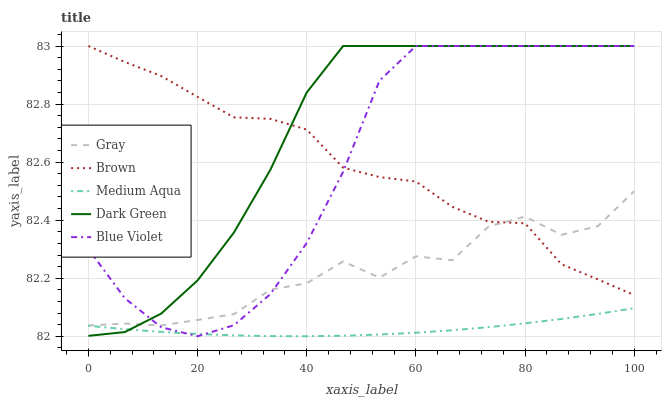Does Medium Aqua have the minimum area under the curve?
Answer yes or no. Yes. Does Dark Green have the maximum area under the curve?
Answer yes or no. Yes. Does Dark Green have the minimum area under the curve?
Answer yes or no. No. Does Medium Aqua have the maximum area under the curve?
Answer yes or no. No. Is Medium Aqua the smoothest?
Answer yes or no. Yes. Is Gray the roughest?
Answer yes or no. Yes. Is Dark Green the smoothest?
Answer yes or no. No. Is Dark Green the roughest?
Answer yes or no. No. Does Blue Violet have the lowest value?
Answer yes or no. Yes. Does Dark Green have the lowest value?
Answer yes or no. No. Does Brown have the highest value?
Answer yes or no. Yes. Does Medium Aqua have the highest value?
Answer yes or no. No. Is Medium Aqua less than Gray?
Answer yes or no. Yes. Is Brown greater than Medium Aqua?
Answer yes or no. Yes. Does Blue Violet intersect Gray?
Answer yes or no. Yes. Is Blue Violet less than Gray?
Answer yes or no. No. Is Blue Violet greater than Gray?
Answer yes or no. No. Does Medium Aqua intersect Gray?
Answer yes or no. No. 